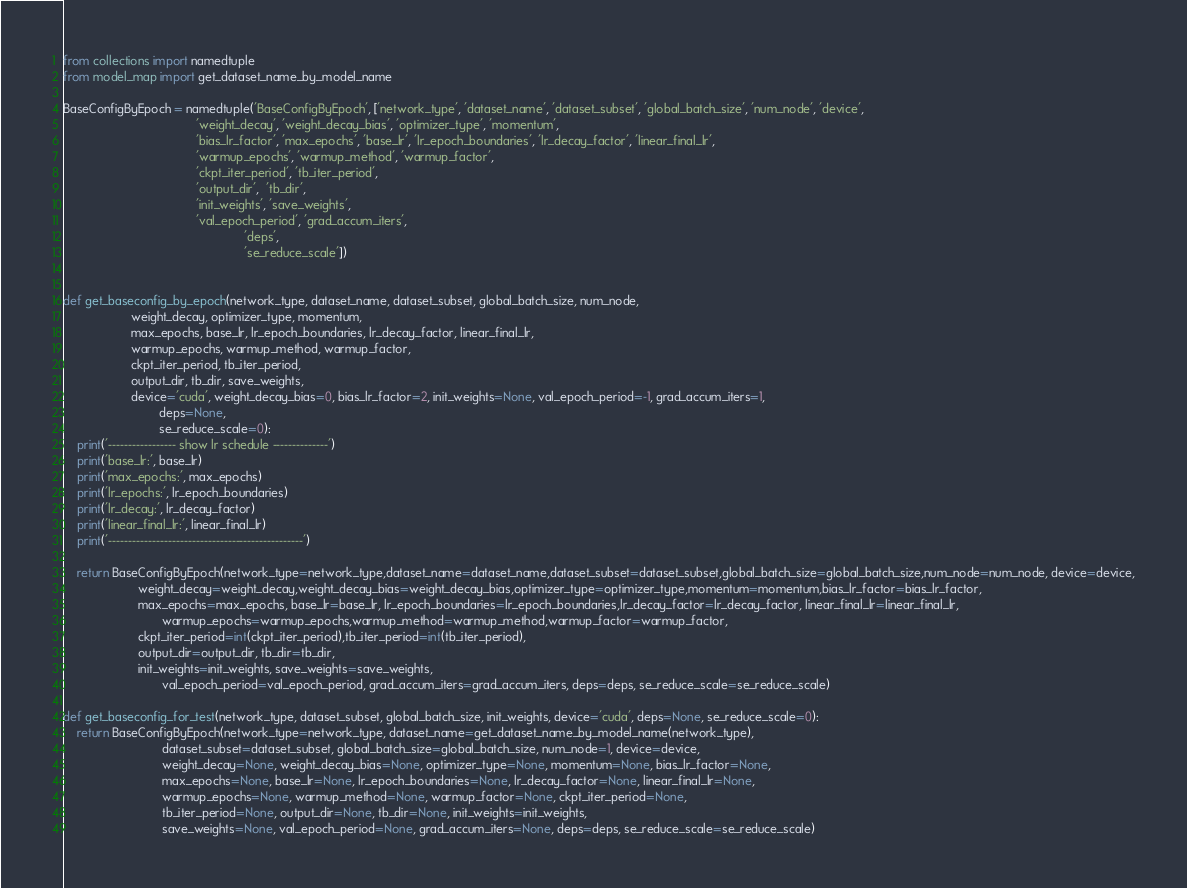Convert code to text. <code><loc_0><loc_0><loc_500><loc_500><_Python_>from collections import namedtuple
from model_map import get_dataset_name_by_model_name

BaseConfigByEpoch = namedtuple('BaseConfigByEpoch', ['network_type', 'dataset_name', 'dataset_subset', 'global_batch_size', 'num_node', 'device',
                                       'weight_decay', 'weight_decay_bias', 'optimizer_type', 'momentum',
                                       'bias_lr_factor', 'max_epochs', 'base_lr', 'lr_epoch_boundaries', 'lr_decay_factor', 'linear_final_lr',
                                       'warmup_epochs', 'warmup_method', 'warmup_factor',
                                       'ckpt_iter_period', 'tb_iter_period',
                                       'output_dir',  'tb_dir',
                                       'init_weights', 'save_weights',
                                       'val_epoch_period', 'grad_accum_iters',
                                                     'deps',
                                                     'se_reduce_scale'])


def get_baseconfig_by_epoch(network_type, dataset_name, dataset_subset, global_batch_size, num_node,
                    weight_decay, optimizer_type, momentum,
                    max_epochs, base_lr, lr_epoch_boundaries, lr_decay_factor, linear_final_lr,
                    warmup_epochs, warmup_method, warmup_factor,
                    ckpt_iter_period, tb_iter_period,
                    output_dir, tb_dir, save_weights,
                    device='cuda', weight_decay_bias=0, bias_lr_factor=2, init_weights=None, val_epoch_period=-1, grad_accum_iters=1,
                            deps=None,
                            se_reduce_scale=0):
    print('----------------- show lr schedule --------------')
    print('base_lr:', base_lr)
    print('max_epochs:', max_epochs)
    print('lr_epochs:', lr_epoch_boundaries)
    print('lr_decay:', lr_decay_factor)
    print('linear_final_lr:', linear_final_lr)
    print('-------------------------------------------------')

    return BaseConfigByEpoch(network_type=network_type,dataset_name=dataset_name,dataset_subset=dataset_subset,global_batch_size=global_batch_size,num_node=num_node, device=device,
                      weight_decay=weight_decay,weight_decay_bias=weight_decay_bias,optimizer_type=optimizer_type,momentum=momentum,bias_lr_factor=bias_lr_factor,
                      max_epochs=max_epochs, base_lr=base_lr, lr_epoch_boundaries=lr_epoch_boundaries,lr_decay_factor=lr_decay_factor, linear_final_lr=linear_final_lr,
                             warmup_epochs=warmup_epochs,warmup_method=warmup_method,warmup_factor=warmup_factor,
                      ckpt_iter_period=int(ckpt_iter_period),tb_iter_period=int(tb_iter_period),
                      output_dir=output_dir, tb_dir=tb_dir,
                      init_weights=init_weights, save_weights=save_weights,
                             val_epoch_period=val_epoch_period, grad_accum_iters=grad_accum_iters, deps=deps, se_reduce_scale=se_reduce_scale)

def get_baseconfig_for_test(network_type, dataset_subset, global_batch_size, init_weights, device='cuda', deps=None, se_reduce_scale=0):
    return BaseConfigByEpoch(network_type=network_type, dataset_name=get_dataset_name_by_model_name(network_type),
                             dataset_subset=dataset_subset, global_batch_size=global_batch_size, num_node=1, device=device,
                             weight_decay=None, weight_decay_bias=None, optimizer_type=None, momentum=None, bias_lr_factor=None,
                             max_epochs=None, base_lr=None, lr_epoch_boundaries=None, lr_decay_factor=None, linear_final_lr=None,
                             warmup_epochs=None, warmup_method=None, warmup_factor=None, ckpt_iter_period=None,
                             tb_iter_period=None, output_dir=None, tb_dir=None, init_weights=init_weights,
                             save_weights=None, val_epoch_period=None, grad_accum_iters=None, deps=deps, se_reduce_scale=se_reduce_scale)</code> 